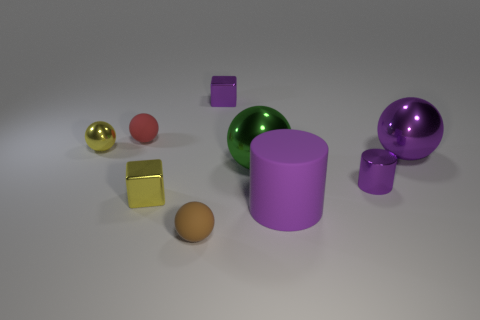What number of other things are there of the same material as the small yellow cube
Your response must be concise. 5. There is a tiny metal cylinder; does it have the same color as the big ball that is to the right of the rubber cylinder?
Your answer should be very brief. Yes. Is the number of tiny purple metallic objects that are to the right of the big cylinder less than the number of purple blocks?
Ensure brevity in your answer.  No. How many large shiny things are there?
Ensure brevity in your answer.  2. There is a large shiny object in front of the large ball that is on the right side of the small purple cylinder; what is its shape?
Give a very brief answer. Sphere. There is a big purple rubber thing; how many things are to the left of it?
Provide a succinct answer. 6. Are the brown sphere and the cube that is to the right of the small brown matte sphere made of the same material?
Provide a short and direct response. No. Is there a cyan matte cylinder of the same size as the purple rubber object?
Make the answer very short. No. Are there the same number of brown spheres that are behind the small yellow metallic ball and red objects?
Offer a terse response. No. The red matte sphere has what size?
Give a very brief answer. Small. 